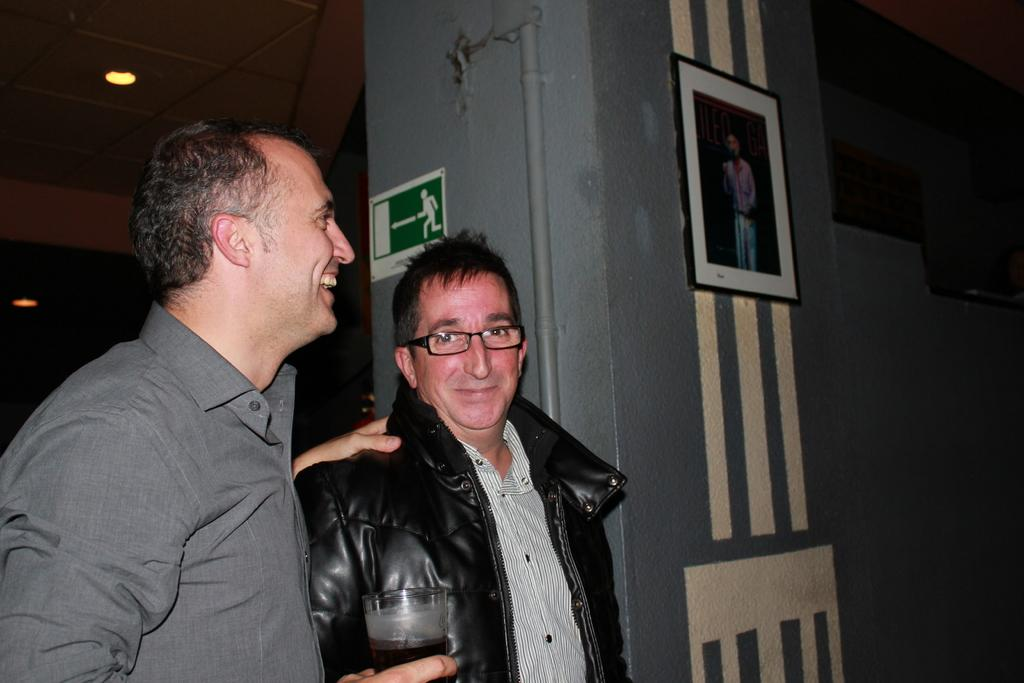How many people are present in the image? There are two men standing in the image. What can be seen behind the men in the image? There is a wall in the image. What object is present on the wall in the image? There is a photo frame in the image. What type of structure is visible in the image? There is a pipe in the image. What is the source of illumination in the image? There is a light in the image. What is above the men in the image? There is a ceiling in the image. What type of clock is hanging on the wall in the image? There is no clock present in the image; only a photo frame is visible on the wall. What type of relation do the two men have in the image? The image does not provide any information about the relationship between the two men. 